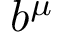Convert formula to latex. <formula><loc_0><loc_0><loc_500><loc_500>b ^ { \mu }</formula> 